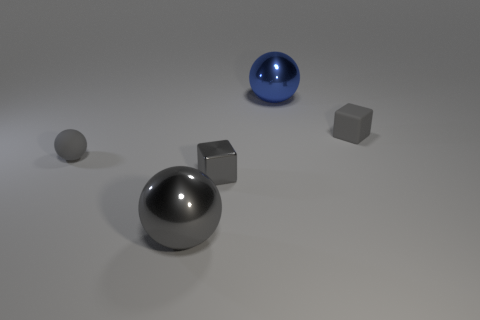Add 4 big blue spheres. How many objects exist? 9 Subtract all small spheres. How many spheres are left? 2 Subtract 2 balls. How many balls are left? 1 Subtract all gray balls. How many purple blocks are left? 0 Subtract all shiny objects. Subtract all large objects. How many objects are left? 0 Add 1 blocks. How many blocks are left? 3 Add 5 large balls. How many large balls exist? 7 Subtract all gray balls. How many balls are left? 1 Subtract 0 cyan blocks. How many objects are left? 5 Subtract all blocks. How many objects are left? 3 